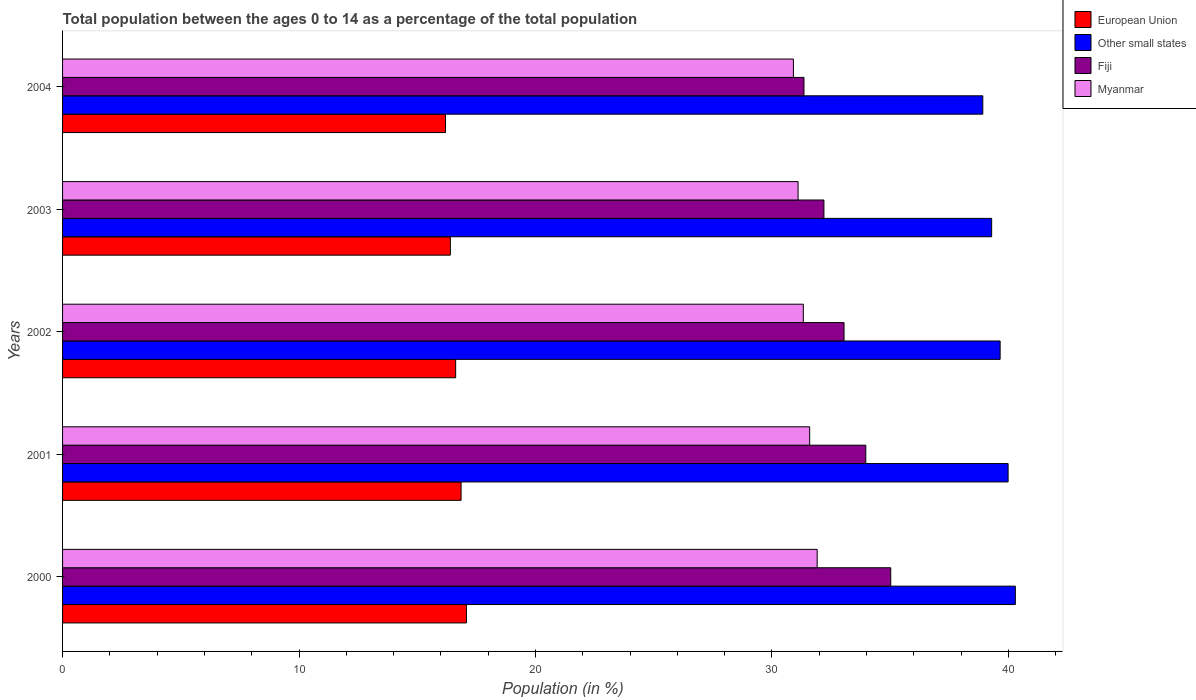How many different coloured bars are there?
Keep it short and to the point. 4. How many groups of bars are there?
Offer a very short reply. 5. Are the number of bars per tick equal to the number of legend labels?
Provide a succinct answer. Yes. Are the number of bars on each tick of the Y-axis equal?
Make the answer very short. Yes. How many bars are there on the 4th tick from the top?
Make the answer very short. 4. In how many cases, is the number of bars for a given year not equal to the number of legend labels?
Ensure brevity in your answer.  0. What is the percentage of the population ages 0 to 14 in European Union in 2004?
Keep it short and to the point. 16.2. Across all years, what is the maximum percentage of the population ages 0 to 14 in Other small states?
Ensure brevity in your answer.  40.3. Across all years, what is the minimum percentage of the population ages 0 to 14 in Fiji?
Make the answer very short. 31.36. What is the total percentage of the population ages 0 to 14 in Other small states in the graph?
Offer a very short reply. 198.15. What is the difference between the percentage of the population ages 0 to 14 in European Union in 2000 and that in 2004?
Offer a very short reply. 0.88. What is the difference between the percentage of the population ages 0 to 14 in Other small states in 2000 and the percentage of the population ages 0 to 14 in Fiji in 2002?
Make the answer very short. 7.24. What is the average percentage of the population ages 0 to 14 in Other small states per year?
Offer a terse response. 39.63. In the year 2004, what is the difference between the percentage of the population ages 0 to 14 in European Union and percentage of the population ages 0 to 14 in Other small states?
Your answer should be compact. -22.72. In how many years, is the percentage of the population ages 0 to 14 in Other small states greater than 40 ?
Give a very brief answer. 1. What is the ratio of the percentage of the population ages 0 to 14 in Fiji in 2000 to that in 2001?
Provide a succinct answer. 1.03. Is the percentage of the population ages 0 to 14 in European Union in 2001 less than that in 2004?
Your answer should be very brief. No. Is the difference between the percentage of the population ages 0 to 14 in European Union in 2003 and 2004 greater than the difference between the percentage of the population ages 0 to 14 in Other small states in 2003 and 2004?
Your response must be concise. No. What is the difference between the highest and the second highest percentage of the population ages 0 to 14 in European Union?
Your response must be concise. 0.23. What is the difference between the highest and the lowest percentage of the population ages 0 to 14 in Myanmar?
Offer a very short reply. 1.01. Is the sum of the percentage of the population ages 0 to 14 in Myanmar in 2000 and 2001 greater than the maximum percentage of the population ages 0 to 14 in European Union across all years?
Your answer should be very brief. Yes. Is it the case that in every year, the sum of the percentage of the population ages 0 to 14 in Other small states and percentage of the population ages 0 to 14 in Fiji is greater than the sum of percentage of the population ages 0 to 14 in Myanmar and percentage of the population ages 0 to 14 in European Union?
Your answer should be compact. No. What does the 3rd bar from the bottom in 2000 represents?
Your answer should be very brief. Fiji. Is it the case that in every year, the sum of the percentage of the population ages 0 to 14 in Other small states and percentage of the population ages 0 to 14 in Fiji is greater than the percentage of the population ages 0 to 14 in Myanmar?
Ensure brevity in your answer.  Yes. How many bars are there?
Your response must be concise. 20. Are all the bars in the graph horizontal?
Ensure brevity in your answer.  Yes. Does the graph contain any zero values?
Make the answer very short. No. Does the graph contain grids?
Give a very brief answer. No. Where does the legend appear in the graph?
Provide a short and direct response. Top right. What is the title of the graph?
Your answer should be compact. Total population between the ages 0 to 14 as a percentage of the total population. Does "Mauritania" appear as one of the legend labels in the graph?
Your response must be concise. No. What is the label or title of the X-axis?
Provide a short and direct response. Population (in %). What is the label or title of the Y-axis?
Provide a short and direct response. Years. What is the Population (in %) in European Union in 2000?
Your answer should be very brief. 17.08. What is the Population (in %) of Other small states in 2000?
Provide a short and direct response. 40.3. What is the Population (in %) in Fiji in 2000?
Make the answer very short. 35.03. What is the Population (in %) in Myanmar in 2000?
Make the answer very short. 31.92. What is the Population (in %) in European Union in 2001?
Your answer should be compact. 16.85. What is the Population (in %) of Other small states in 2001?
Offer a very short reply. 39.99. What is the Population (in %) in Fiji in 2001?
Ensure brevity in your answer.  33.97. What is the Population (in %) of Myanmar in 2001?
Offer a terse response. 31.6. What is the Population (in %) in European Union in 2002?
Provide a short and direct response. 16.62. What is the Population (in %) of Other small states in 2002?
Offer a very short reply. 39.65. What is the Population (in %) of Fiji in 2002?
Ensure brevity in your answer.  33.05. What is the Population (in %) in Myanmar in 2002?
Offer a terse response. 31.33. What is the Population (in %) of European Union in 2003?
Your response must be concise. 16.4. What is the Population (in %) in Other small states in 2003?
Make the answer very short. 39.29. What is the Population (in %) in Fiji in 2003?
Ensure brevity in your answer.  32.2. What is the Population (in %) of Myanmar in 2003?
Offer a terse response. 31.11. What is the Population (in %) in European Union in 2004?
Give a very brief answer. 16.2. What is the Population (in %) in Other small states in 2004?
Give a very brief answer. 38.92. What is the Population (in %) in Fiji in 2004?
Ensure brevity in your answer.  31.36. What is the Population (in %) in Myanmar in 2004?
Give a very brief answer. 30.91. Across all years, what is the maximum Population (in %) of European Union?
Provide a short and direct response. 17.08. Across all years, what is the maximum Population (in %) of Other small states?
Your answer should be very brief. 40.3. Across all years, what is the maximum Population (in %) of Fiji?
Provide a short and direct response. 35.03. Across all years, what is the maximum Population (in %) in Myanmar?
Offer a very short reply. 31.92. Across all years, what is the minimum Population (in %) of European Union?
Offer a very short reply. 16.2. Across all years, what is the minimum Population (in %) in Other small states?
Offer a terse response. 38.92. Across all years, what is the minimum Population (in %) of Fiji?
Offer a very short reply. 31.36. Across all years, what is the minimum Population (in %) in Myanmar?
Your answer should be compact. 30.91. What is the total Population (in %) of European Union in the graph?
Your response must be concise. 83.16. What is the total Population (in %) of Other small states in the graph?
Give a very brief answer. 198.15. What is the total Population (in %) of Fiji in the graph?
Provide a succinct answer. 165.61. What is the total Population (in %) of Myanmar in the graph?
Ensure brevity in your answer.  156.86. What is the difference between the Population (in %) of European Union in 2000 and that in 2001?
Make the answer very short. 0.23. What is the difference between the Population (in %) of Other small states in 2000 and that in 2001?
Make the answer very short. 0.31. What is the difference between the Population (in %) of Fiji in 2000 and that in 2001?
Give a very brief answer. 1.05. What is the difference between the Population (in %) of Myanmar in 2000 and that in 2001?
Provide a short and direct response. 0.32. What is the difference between the Population (in %) in European Union in 2000 and that in 2002?
Keep it short and to the point. 0.46. What is the difference between the Population (in %) in Other small states in 2000 and that in 2002?
Ensure brevity in your answer.  0.64. What is the difference between the Population (in %) of Fiji in 2000 and that in 2002?
Offer a very short reply. 1.97. What is the difference between the Population (in %) of Myanmar in 2000 and that in 2002?
Give a very brief answer. 0.59. What is the difference between the Population (in %) in European Union in 2000 and that in 2003?
Your answer should be very brief. 0.68. What is the difference between the Population (in %) in Other small states in 2000 and that in 2003?
Keep it short and to the point. 1. What is the difference between the Population (in %) in Fiji in 2000 and that in 2003?
Give a very brief answer. 2.83. What is the difference between the Population (in %) of Myanmar in 2000 and that in 2003?
Make the answer very short. 0.81. What is the difference between the Population (in %) in European Union in 2000 and that in 2004?
Your response must be concise. 0.88. What is the difference between the Population (in %) of Other small states in 2000 and that in 2004?
Your answer should be compact. 1.38. What is the difference between the Population (in %) of Fiji in 2000 and that in 2004?
Your answer should be compact. 3.67. What is the difference between the Population (in %) in Myanmar in 2000 and that in 2004?
Keep it short and to the point. 1.01. What is the difference between the Population (in %) in European Union in 2001 and that in 2002?
Your answer should be very brief. 0.23. What is the difference between the Population (in %) of Other small states in 2001 and that in 2002?
Your answer should be very brief. 0.34. What is the difference between the Population (in %) in Myanmar in 2001 and that in 2002?
Make the answer very short. 0.27. What is the difference between the Population (in %) of European Union in 2001 and that in 2003?
Provide a succinct answer. 0.45. What is the difference between the Population (in %) in Other small states in 2001 and that in 2003?
Ensure brevity in your answer.  0.7. What is the difference between the Population (in %) in Fiji in 2001 and that in 2003?
Provide a short and direct response. 1.77. What is the difference between the Population (in %) of Myanmar in 2001 and that in 2003?
Ensure brevity in your answer.  0.49. What is the difference between the Population (in %) in European Union in 2001 and that in 2004?
Ensure brevity in your answer.  0.66. What is the difference between the Population (in %) in Other small states in 2001 and that in 2004?
Your response must be concise. 1.07. What is the difference between the Population (in %) of Fiji in 2001 and that in 2004?
Your answer should be very brief. 2.61. What is the difference between the Population (in %) in Myanmar in 2001 and that in 2004?
Offer a very short reply. 0.69. What is the difference between the Population (in %) in European Union in 2002 and that in 2003?
Your answer should be compact. 0.22. What is the difference between the Population (in %) in Other small states in 2002 and that in 2003?
Your response must be concise. 0.36. What is the difference between the Population (in %) of Fiji in 2002 and that in 2003?
Make the answer very short. 0.85. What is the difference between the Population (in %) in Myanmar in 2002 and that in 2003?
Your response must be concise. 0.22. What is the difference between the Population (in %) of European Union in 2002 and that in 2004?
Ensure brevity in your answer.  0.43. What is the difference between the Population (in %) of Other small states in 2002 and that in 2004?
Make the answer very short. 0.73. What is the difference between the Population (in %) of Fiji in 2002 and that in 2004?
Give a very brief answer. 1.69. What is the difference between the Population (in %) in Myanmar in 2002 and that in 2004?
Make the answer very short. 0.42. What is the difference between the Population (in %) of European Union in 2003 and that in 2004?
Give a very brief answer. 0.2. What is the difference between the Population (in %) of Other small states in 2003 and that in 2004?
Offer a terse response. 0.37. What is the difference between the Population (in %) in Fiji in 2003 and that in 2004?
Your answer should be very brief. 0.84. What is the difference between the Population (in %) of Myanmar in 2003 and that in 2004?
Ensure brevity in your answer.  0.2. What is the difference between the Population (in %) of European Union in 2000 and the Population (in %) of Other small states in 2001?
Your answer should be very brief. -22.91. What is the difference between the Population (in %) of European Union in 2000 and the Population (in %) of Fiji in 2001?
Offer a terse response. -16.89. What is the difference between the Population (in %) of European Union in 2000 and the Population (in %) of Myanmar in 2001?
Make the answer very short. -14.52. What is the difference between the Population (in %) of Other small states in 2000 and the Population (in %) of Fiji in 2001?
Offer a very short reply. 6.32. What is the difference between the Population (in %) in Other small states in 2000 and the Population (in %) in Myanmar in 2001?
Give a very brief answer. 8.7. What is the difference between the Population (in %) in Fiji in 2000 and the Population (in %) in Myanmar in 2001?
Ensure brevity in your answer.  3.43. What is the difference between the Population (in %) in European Union in 2000 and the Population (in %) in Other small states in 2002?
Provide a succinct answer. -22.57. What is the difference between the Population (in %) in European Union in 2000 and the Population (in %) in Fiji in 2002?
Offer a terse response. -15.97. What is the difference between the Population (in %) of European Union in 2000 and the Population (in %) of Myanmar in 2002?
Offer a very short reply. -14.25. What is the difference between the Population (in %) of Other small states in 2000 and the Population (in %) of Fiji in 2002?
Your answer should be compact. 7.24. What is the difference between the Population (in %) in Other small states in 2000 and the Population (in %) in Myanmar in 2002?
Make the answer very short. 8.97. What is the difference between the Population (in %) in Fiji in 2000 and the Population (in %) in Myanmar in 2002?
Your answer should be very brief. 3.7. What is the difference between the Population (in %) of European Union in 2000 and the Population (in %) of Other small states in 2003?
Ensure brevity in your answer.  -22.21. What is the difference between the Population (in %) of European Union in 2000 and the Population (in %) of Fiji in 2003?
Your answer should be compact. -15.12. What is the difference between the Population (in %) in European Union in 2000 and the Population (in %) in Myanmar in 2003?
Provide a short and direct response. -14.03. What is the difference between the Population (in %) of Other small states in 2000 and the Population (in %) of Fiji in 2003?
Provide a short and direct response. 8.1. What is the difference between the Population (in %) of Other small states in 2000 and the Population (in %) of Myanmar in 2003?
Your answer should be very brief. 9.19. What is the difference between the Population (in %) in Fiji in 2000 and the Population (in %) in Myanmar in 2003?
Offer a terse response. 3.92. What is the difference between the Population (in %) of European Union in 2000 and the Population (in %) of Other small states in 2004?
Offer a very short reply. -21.84. What is the difference between the Population (in %) of European Union in 2000 and the Population (in %) of Fiji in 2004?
Your answer should be very brief. -14.28. What is the difference between the Population (in %) in European Union in 2000 and the Population (in %) in Myanmar in 2004?
Your answer should be very brief. -13.83. What is the difference between the Population (in %) in Other small states in 2000 and the Population (in %) in Fiji in 2004?
Provide a short and direct response. 8.94. What is the difference between the Population (in %) in Other small states in 2000 and the Population (in %) in Myanmar in 2004?
Ensure brevity in your answer.  9.39. What is the difference between the Population (in %) of Fiji in 2000 and the Population (in %) of Myanmar in 2004?
Keep it short and to the point. 4.12. What is the difference between the Population (in %) in European Union in 2001 and the Population (in %) in Other small states in 2002?
Provide a short and direct response. -22.8. What is the difference between the Population (in %) of European Union in 2001 and the Population (in %) of Fiji in 2002?
Your answer should be compact. -16.2. What is the difference between the Population (in %) in European Union in 2001 and the Population (in %) in Myanmar in 2002?
Your answer should be very brief. -14.48. What is the difference between the Population (in %) of Other small states in 2001 and the Population (in %) of Fiji in 2002?
Ensure brevity in your answer.  6.94. What is the difference between the Population (in %) of Other small states in 2001 and the Population (in %) of Myanmar in 2002?
Your answer should be compact. 8.66. What is the difference between the Population (in %) of Fiji in 2001 and the Population (in %) of Myanmar in 2002?
Your answer should be very brief. 2.64. What is the difference between the Population (in %) in European Union in 2001 and the Population (in %) in Other small states in 2003?
Ensure brevity in your answer.  -22.44. What is the difference between the Population (in %) in European Union in 2001 and the Population (in %) in Fiji in 2003?
Your response must be concise. -15.35. What is the difference between the Population (in %) in European Union in 2001 and the Population (in %) in Myanmar in 2003?
Your response must be concise. -14.25. What is the difference between the Population (in %) of Other small states in 2001 and the Population (in %) of Fiji in 2003?
Your answer should be very brief. 7.79. What is the difference between the Population (in %) of Other small states in 2001 and the Population (in %) of Myanmar in 2003?
Your answer should be compact. 8.88. What is the difference between the Population (in %) in Fiji in 2001 and the Population (in %) in Myanmar in 2003?
Provide a short and direct response. 2.86. What is the difference between the Population (in %) of European Union in 2001 and the Population (in %) of Other small states in 2004?
Keep it short and to the point. -22.07. What is the difference between the Population (in %) of European Union in 2001 and the Population (in %) of Fiji in 2004?
Provide a short and direct response. -14.5. What is the difference between the Population (in %) of European Union in 2001 and the Population (in %) of Myanmar in 2004?
Provide a short and direct response. -14.06. What is the difference between the Population (in %) of Other small states in 2001 and the Population (in %) of Fiji in 2004?
Ensure brevity in your answer.  8.63. What is the difference between the Population (in %) in Other small states in 2001 and the Population (in %) in Myanmar in 2004?
Ensure brevity in your answer.  9.08. What is the difference between the Population (in %) of Fiji in 2001 and the Population (in %) of Myanmar in 2004?
Keep it short and to the point. 3.06. What is the difference between the Population (in %) of European Union in 2002 and the Population (in %) of Other small states in 2003?
Offer a very short reply. -22.67. What is the difference between the Population (in %) in European Union in 2002 and the Population (in %) in Fiji in 2003?
Your answer should be compact. -15.58. What is the difference between the Population (in %) in European Union in 2002 and the Population (in %) in Myanmar in 2003?
Provide a succinct answer. -14.48. What is the difference between the Population (in %) in Other small states in 2002 and the Population (in %) in Fiji in 2003?
Your response must be concise. 7.45. What is the difference between the Population (in %) of Other small states in 2002 and the Population (in %) of Myanmar in 2003?
Ensure brevity in your answer.  8.55. What is the difference between the Population (in %) in Fiji in 2002 and the Population (in %) in Myanmar in 2003?
Give a very brief answer. 1.94. What is the difference between the Population (in %) in European Union in 2002 and the Population (in %) in Other small states in 2004?
Keep it short and to the point. -22.29. What is the difference between the Population (in %) of European Union in 2002 and the Population (in %) of Fiji in 2004?
Your answer should be compact. -14.73. What is the difference between the Population (in %) in European Union in 2002 and the Population (in %) in Myanmar in 2004?
Your response must be concise. -14.29. What is the difference between the Population (in %) of Other small states in 2002 and the Population (in %) of Fiji in 2004?
Make the answer very short. 8.3. What is the difference between the Population (in %) in Other small states in 2002 and the Population (in %) in Myanmar in 2004?
Offer a terse response. 8.74. What is the difference between the Population (in %) of Fiji in 2002 and the Population (in %) of Myanmar in 2004?
Your response must be concise. 2.14. What is the difference between the Population (in %) of European Union in 2003 and the Population (in %) of Other small states in 2004?
Your answer should be very brief. -22.52. What is the difference between the Population (in %) of European Union in 2003 and the Population (in %) of Fiji in 2004?
Provide a short and direct response. -14.96. What is the difference between the Population (in %) of European Union in 2003 and the Population (in %) of Myanmar in 2004?
Ensure brevity in your answer.  -14.51. What is the difference between the Population (in %) of Other small states in 2003 and the Population (in %) of Fiji in 2004?
Keep it short and to the point. 7.94. What is the difference between the Population (in %) of Other small states in 2003 and the Population (in %) of Myanmar in 2004?
Your answer should be very brief. 8.38. What is the difference between the Population (in %) in Fiji in 2003 and the Population (in %) in Myanmar in 2004?
Provide a succinct answer. 1.29. What is the average Population (in %) in European Union per year?
Keep it short and to the point. 16.63. What is the average Population (in %) in Other small states per year?
Keep it short and to the point. 39.63. What is the average Population (in %) of Fiji per year?
Offer a terse response. 33.12. What is the average Population (in %) of Myanmar per year?
Your response must be concise. 31.37. In the year 2000, what is the difference between the Population (in %) of European Union and Population (in %) of Other small states?
Your answer should be very brief. -23.21. In the year 2000, what is the difference between the Population (in %) in European Union and Population (in %) in Fiji?
Provide a short and direct response. -17.95. In the year 2000, what is the difference between the Population (in %) in European Union and Population (in %) in Myanmar?
Provide a short and direct response. -14.83. In the year 2000, what is the difference between the Population (in %) in Other small states and Population (in %) in Fiji?
Offer a terse response. 5.27. In the year 2000, what is the difference between the Population (in %) of Other small states and Population (in %) of Myanmar?
Ensure brevity in your answer.  8.38. In the year 2000, what is the difference between the Population (in %) in Fiji and Population (in %) in Myanmar?
Give a very brief answer. 3.11. In the year 2001, what is the difference between the Population (in %) in European Union and Population (in %) in Other small states?
Your response must be concise. -23.14. In the year 2001, what is the difference between the Population (in %) in European Union and Population (in %) in Fiji?
Provide a short and direct response. -17.12. In the year 2001, what is the difference between the Population (in %) of European Union and Population (in %) of Myanmar?
Your answer should be compact. -14.74. In the year 2001, what is the difference between the Population (in %) in Other small states and Population (in %) in Fiji?
Keep it short and to the point. 6.02. In the year 2001, what is the difference between the Population (in %) in Other small states and Population (in %) in Myanmar?
Your answer should be very brief. 8.39. In the year 2001, what is the difference between the Population (in %) of Fiji and Population (in %) of Myanmar?
Give a very brief answer. 2.37. In the year 2002, what is the difference between the Population (in %) of European Union and Population (in %) of Other small states?
Ensure brevity in your answer.  -23.03. In the year 2002, what is the difference between the Population (in %) of European Union and Population (in %) of Fiji?
Your response must be concise. -16.43. In the year 2002, what is the difference between the Population (in %) of European Union and Population (in %) of Myanmar?
Offer a terse response. -14.7. In the year 2002, what is the difference between the Population (in %) in Other small states and Population (in %) in Fiji?
Provide a succinct answer. 6.6. In the year 2002, what is the difference between the Population (in %) of Other small states and Population (in %) of Myanmar?
Provide a succinct answer. 8.32. In the year 2002, what is the difference between the Population (in %) of Fiji and Population (in %) of Myanmar?
Your answer should be very brief. 1.72. In the year 2003, what is the difference between the Population (in %) in European Union and Population (in %) in Other small states?
Your answer should be compact. -22.89. In the year 2003, what is the difference between the Population (in %) in European Union and Population (in %) in Fiji?
Offer a terse response. -15.8. In the year 2003, what is the difference between the Population (in %) in European Union and Population (in %) in Myanmar?
Make the answer very short. -14.71. In the year 2003, what is the difference between the Population (in %) of Other small states and Population (in %) of Fiji?
Give a very brief answer. 7.09. In the year 2003, what is the difference between the Population (in %) of Other small states and Population (in %) of Myanmar?
Your answer should be compact. 8.19. In the year 2003, what is the difference between the Population (in %) of Fiji and Population (in %) of Myanmar?
Your answer should be compact. 1.09. In the year 2004, what is the difference between the Population (in %) of European Union and Population (in %) of Other small states?
Your answer should be very brief. -22.72. In the year 2004, what is the difference between the Population (in %) in European Union and Population (in %) in Fiji?
Give a very brief answer. -15.16. In the year 2004, what is the difference between the Population (in %) in European Union and Population (in %) in Myanmar?
Your answer should be compact. -14.71. In the year 2004, what is the difference between the Population (in %) in Other small states and Population (in %) in Fiji?
Give a very brief answer. 7.56. In the year 2004, what is the difference between the Population (in %) of Other small states and Population (in %) of Myanmar?
Your answer should be very brief. 8.01. In the year 2004, what is the difference between the Population (in %) of Fiji and Population (in %) of Myanmar?
Keep it short and to the point. 0.45. What is the ratio of the Population (in %) in European Union in 2000 to that in 2001?
Keep it short and to the point. 1.01. What is the ratio of the Population (in %) in Other small states in 2000 to that in 2001?
Provide a succinct answer. 1.01. What is the ratio of the Population (in %) in Fiji in 2000 to that in 2001?
Your answer should be compact. 1.03. What is the ratio of the Population (in %) in Myanmar in 2000 to that in 2001?
Your response must be concise. 1.01. What is the ratio of the Population (in %) of European Union in 2000 to that in 2002?
Make the answer very short. 1.03. What is the ratio of the Population (in %) of Other small states in 2000 to that in 2002?
Make the answer very short. 1.02. What is the ratio of the Population (in %) in Fiji in 2000 to that in 2002?
Give a very brief answer. 1.06. What is the ratio of the Population (in %) of Myanmar in 2000 to that in 2002?
Offer a terse response. 1.02. What is the ratio of the Population (in %) of European Union in 2000 to that in 2003?
Provide a succinct answer. 1.04. What is the ratio of the Population (in %) in Other small states in 2000 to that in 2003?
Keep it short and to the point. 1.03. What is the ratio of the Population (in %) in Fiji in 2000 to that in 2003?
Provide a succinct answer. 1.09. What is the ratio of the Population (in %) in European Union in 2000 to that in 2004?
Provide a short and direct response. 1.05. What is the ratio of the Population (in %) in Other small states in 2000 to that in 2004?
Offer a terse response. 1.04. What is the ratio of the Population (in %) in Fiji in 2000 to that in 2004?
Provide a succinct answer. 1.12. What is the ratio of the Population (in %) in Myanmar in 2000 to that in 2004?
Offer a very short reply. 1.03. What is the ratio of the Population (in %) in European Union in 2001 to that in 2002?
Keep it short and to the point. 1.01. What is the ratio of the Population (in %) in Other small states in 2001 to that in 2002?
Ensure brevity in your answer.  1.01. What is the ratio of the Population (in %) of Fiji in 2001 to that in 2002?
Your response must be concise. 1.03. What is the ratio of the Population (in %) in Myanmar in 2001 to that in 2002?
Offer a terse response. 1.01. What is the ratio of the Population (in %) of European Union in 2001 to that in 2003?
Your answer should be very brief. 1.03. What is the ratio of the Population (in %) in Other small states in 2001 to that in 2003?
Your answer should be very brief. 1.02. What is the ratio of the Population (in %) of Fiji in 2001 to that in 2003?
Give a very brief answer. 1.05. What is the ratio of the Population (in %) of Myanmar in 2001 to that in 2003?
Make the answer very short. 1.02. What is the ratio of the Population (in %) in European Union in 2001 to that in 2004?
Make the answer very short. 1.04. What is the ratio of the Population (in %) of Other small states in 2001 to that in 2004?
Ensure brevity in your answer.  1.03. What is the ratio of the Population (in %) in Fiji in 2001 to that in 2004?
Offer a very short reply. 1.08. What is the ratio of the Population (in %) of Myanmar in 2001 to that in 2004?
Give a very brief answer. 1.02. What is the ratio of the Population (in %) of European Union in 2002 to that in 2003?
Make the answer very short. 1.01. What is the ratio of the Population (in %) in Other small states in 2002 to that in 2003?
Provide a short and direct response. 1.01. What is the ratio of the Population (in %) in Fiji in 2002 to that in 2003?
Keep it short and to the point. 1.03. What is the ratio of the Population (in %) in Myanmar in 2002 to that in 2003?
Give a very brief answer. 1.01. What is the ratio of the Population (in %) in European Union in 2002 to that in 2004?
Give a very brief answer. 1.03. What is the ratio of the Population (in %) of Other small states in 2002 to that in 2004?
Your answer should be compact. 1.02. What is the ratio of the Population (in %) of Fiji in 2002 to that in 2004?
Keep it short and to the point. 1.05. What is the ratio of the Population (in %) in Myanmar in 2002 to that in 2004?
Offer a very short reply. 1.01. What is the ratio of the Population (in %) in European Union in 2003 to that in 2004?
Your response must be concise. 1.01. What is the ratio of the Population (in %) in Other small states in 2003 to that in 2004?
Your response must be concise. 1.01. What is the ratio of the Population (in %) in Fiji in 2003 to that in 2004?
Your answer should be very brief. 1.03. What is the ratio of the Population (in %) in Myanmar in 2003 to that in 2004?
Offer a terse response. 1.01. What is the difference between the highest and the second highest Population (in %) of European Union?
Make the answer very short. 0.23. What is the difference between the highest and the second highest Population (in %) in Other small states?
Give a very brief answer. 0.31. What is the difference between the highest and the second highest Population (in %) of Fiji?
Your response must be concise. 1.05. What is the difference between the highest and the second highest Population (in %) in Myanmar?
Your response must be concise. 0.32. What is the difference between the highest and the lowest Population (in %) of European Union?
Your response must be concise. 0.88. What is the difference between the highest and the lowest Population (in %) in Other small states?
Ensure brevity in your answer.  1.38. What is the difference between the highest and the lowest Population (in %) of Fiji?
Your response must be concise. 3.67. 